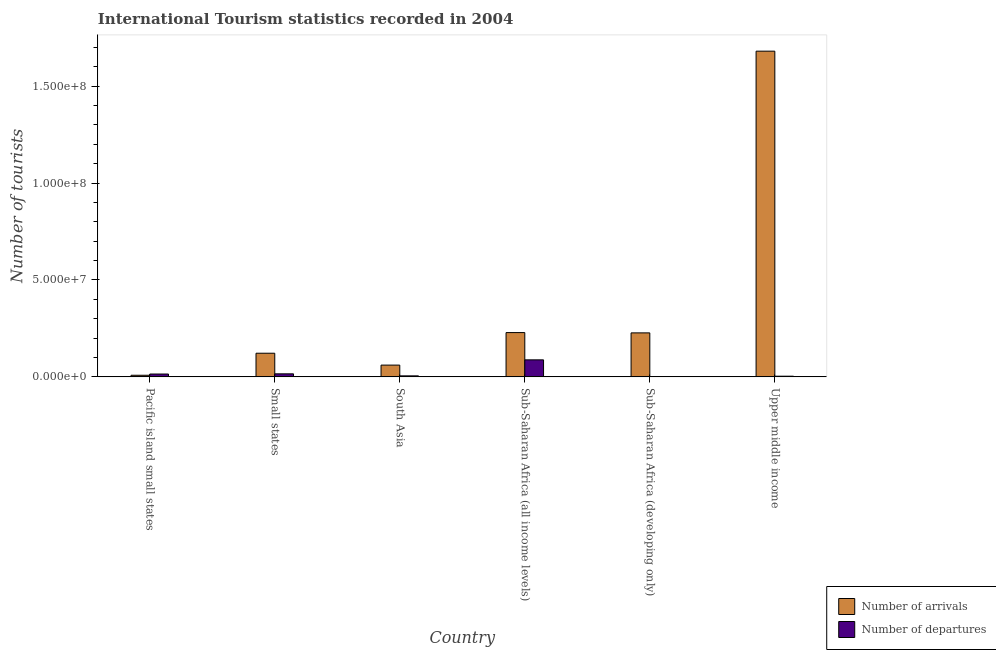Are the number of bars on each tick of the X-axis equal?
Your answer should be compact. Yes. What is the label of the 6th group of bars from the left?
Give a very brief answer. Upper middle income. In how many cases, is the number of bars for a given country not equal to the number of legend labels?
Provide a short and direct response. 0. What is the number of tourist arrivals in Upper middle income?
Ensure brevity in your answer.  1.68e+08. Across all countries, what is the maximum number of tourist arrivals?
Your answer should be compact. 1.68e+08. Across all countries, what is the minimum number of tourist departures?
Ensure brevity in your answer.  1.56e+05. In which country was the number of tourist departures maximum?
Your response must be concise. Sub-Saharan Africa (all income levels). In which country was the number of tourist arrivals minimum?
Give a very brief answer. Pacific island small states. What is the total number of tourist arrivals in the graph?
Provide a succinct answer. 2.33e+08. What is the difference between the number of tourist departures in South Asia and that in Sub-Saharan Africa (all income levels)?
Your response must be concise. -8.27e+06. What is the difference between the number of tourist arrivals in Small states and the number of tourist departures in Sub-Saharan Africa (developing only)?
Offer a very short reply. 1.20e+07. What is the average number of tourist departures per country?
Make the answer very short. 2.14e+06. What is the difference between the number of tourist arrivals and number of tourist departures in South Asia?
Offer a very short reply. 5.56e+06. What is the ratio of the number of tourist arrivals in Pacific island small states to that in Small states?
Offer a terse response. 0.07. What is the difference between the highest and the second highest number of tourist arrivals?
Give a very brief answer. 1.45e+08. What is the difference between the highest and the lowest number of tourist arrivals?
Your answer should be compact. 1.67e+08. In how many countries, is the number of tourist arrivals greater than the average number of tourist arrivals taken over all countries?
Keep it short and to the point. 1. Is the sum of the number of tourist arrivals in Small states and Sub-Saharan Africa (developing only) greater than the maximum number of tourist departures across all countries?
Keep it short and to the point. Yes. What does the 1st bar from the left in South Asia represents?
Offer a very short reply. Number of arrivals. What does the 2nd bar from the right in Upper middle income represents?
Ensure brevity in your answer.  Number of arrivals. How many bars are there?
Keep it short and to the point. 12. Are all the bars in the graph horizontal?
Keep it short and to the point. No. Does the graph contain any zero values?
Ensure brevity in your answer.  No. How many legend labels are there?
Offer a terse response. 2. How are the legend labels stacked?
Keep it short and to the point. Vertical. What is the title of the graph?
Offer a very short reply. International Tourism statistics recorded in 2004. Does "Girls" appear as one of the legend labels in the graph?
Offer a very short reply. No. What is the label or title of the Y-axis?
Offer a terse response. Number of tourists. What is the Number of tourists of Number of arrivals in Pacific island small states?
Your answer should be very brief. 8.31e+05. What is the Number of tourists of Number of departures in Pacific island small states?
Keep it short and to the point. 1.47e+06. What is the Number of tourists in Number of arrivals in Small states?
Provide a short and direct response. 1.22e+07. What is the Number of tourists of Number of departures in Small states?
Your answer should be compact. 1.56e+06. What is the Number of tourists in Number of arrivals in South Asia?
Your answer should be very brief. 6.07e+06. What is the Number of tourists of Number of departures in South Asia?
Offer a very short reply. 5.15e+05. What is the Number of tourists of Number of arrivals in Sub-Saharan Africa (all income levels)?
Provide a short and direct response. 2.28e+07. What is the Number of tourists of Number of departures in Sub-Saharan Africa (all income levels)?
Your answer should be very brief. 8.78e+06. What is the Number of tourists of Number of arrivals in Sub-Saharan Africa (developing only)?
Provide a succinct answer. 2.27e+07. What is the Number of tourists in Number of departures in Sub-Saharan Africa (developing only)?
Ensure brevity in your answer.  1.56e+05. What is the Number of tourists in Number of arrivals in Upper middle income?
Give a very brief answer. 1.68e+08. What is the Number of tourists in Number of departures in Upper middle income?
Give a very brief answer. 3.46e+05. Across all countries, what is the maximum Number of tourists of Number of arrivals?
Your response must be concise. 1.68e+08. Across all countries, what is the maximum Number of tourists of Number of departures?
Make the answer very short. 8.78e+06. Across all countries, what is the minimum Number of tourists in Number of arrivals?
Offer a terse response. 8.31e+05. Across all countries, what is the minimum Number of tourists of Number of departures?
Give a very brief answer. 1.56e+05. What is the total Number of tourists of Number of arrivals in the graph?
Offer a very short reply. 2.33e+08. What is the total Number of tourists in Number of departures in the graph?
Your answer should be compact. 1.28e+07. What is the difference between the Number of tourists in Number of arrivals in Pacific island small states and that in Small states?
Offer a very short reply. -1.14e+07. What is the difference between the Number of tourists in Number of departures in Pacific island small states and that in Small states?
Provide a short and direct response. -9.20e+04. What is the difference between the Number of tourists of Number of arrivals in Pacific island small states and that in South Asia?
Your answer should be compact. -5.24e+06. What is the difference between the Number of tourists of Number of departures in Pacific island small states and that in South Asia?
Ensure brevity in your answer.  9.58e+05. What is the difference between the Number of tourists in Number of arrivals in Pacific island small states and that in Sub-Saharan Africa (all income levels)?
Your answer should be very brief. -2.20e+07. What is the difference between the Number of tourists of Number of departures in Pacific island small states and that in Sub-Saharan Africa (all income levels)?
Provide a short and direct response. -7.31e+06. What is the difference between the Number of tourists of Number of arrivals in Pacific island small states and that in Sub-Saharan Africa (developing only)?
Your answer should be very brief. -2.19e+07. What is the difference between the Number of tourists of Number of departures in Pacific island small states and that in Sub-Saharan Africa (developing only)?
Make the answer very short. 1.32e+06. What is the difference between the Number of tourists in Number of arrivals in Pacific island small states and that in Upper middle income?
Provide a short and direct response. -1.67e+08. What is the difference between the Number of tourists in Number of departures in Pacific island small states and that in Upper middle income?
Your answer should be very brief. 1.13e+06. What is the difference between the Number of tourists of Number of arrivals in Small states and that in South Asia?
Keep it short and to the point. 6.12e+06. What is the difference between the Number of tourists in Number of departures in Small states and that in South Asia?
Ensure brevity in your answer.  1.05e+06. What is the difference between the Number of tourists of Number of arrivals in Small states and that in Sub-Saharan Africa (all income levels)?
Offer a terse response. -1.07e+07. What is the difference between the Number of tourists of Number of departures in Small states and that in Sub-Saharan Africa (all income levels)?
Offer a very short reply. -7.22e+06. What is the difference between the Number of tourists in Number of arrivals in Small states and that in Sub-Saharan Africa (developing only)?
Provide a succinct answer. -1.05e+07. What is the difference between the Number of tourists of Number of departures in Small states and that in Sub-Saharan Africa (developing only)?
Provide a succinct answer. 1.41e+06. What is the difference between the Number of tourists of Number of arrivals in Small states and that in Upper middle income?
Ensure brevity in your answer.  -1.56e+08. What is the difference between the Number of tourists of Number of departures in Small states and that in Upper middle income?
Provide a succinct answer. 1.22e+06. What is the difference between the Number of tourists in Number of arrivals in South Asia and that in Sub-Saharan Africa (all income levels)?
Your answer should be very brief. -1.68e+07. What is the difference between the Number of tourists of Number of departures in South Asia and that in Sub-Saharan Africa (all income levels)?
Keep it short and to the point. -8.27e+06. What is the difference between the Number of tourists of Number of arrivals in South Asia and that in Sub-Saharan Africa (developing only)?
Your response must be concise. -1.66e+07. What is the difference between the Number of tourists of Number of departures in South Asia and that in Sub-Saharan Africa (developing only)?
Your answer should be compact. 3.59e+05. What is the difference between the Number of tourists of Number of arrivals in South Asia and that in Upper middle income?
Your response must be concise. -1.62e+08. What is the difference between the Number of tourists in Number of departures in South Asia and that in Upper middle income?
Keep it short and to the point. 1.69e+05. What is the difference between the Number of tourists in Number of arrivals in Sub-Saharan Africa (all income levels) and that in Sub-Saharan Africa (developing only)?
Your response must be concise. 1.53e+05. What is the difference between the Number of tourists of Number of departures in Sub-Saharan Africa (all income levels) and that in Sub-Saharan Africa (developing only)?
Give a very brief answer. 8.63e+06. What is the difference between the Number of tourists of Number of arrivals in Sub-Saharan Africa (all income levels) and that in Upper middle income?
Offer a very short reply. -1.45e+08. What is the difference between the Number of tourists of Number of departures in Sub-Saharan Africa (all income levels) and that in Upper middle income?
Offer a terse response. 8.44e+06. What is the difference between the Number of tourists of Number of arrivals in Sub-Saharan Africa (developing only) and that in Upper middle income?
Offer a very short reply. -1.45e+08. What is the difference between the Number of tourists of Number of arrivals in Pacific island small states and the Number of tourists of Number of departures in Small states?
Your answer should be very brief. -7.34e+05. What is the difference between the Number of tourists of Number of arrivals in Pacific island small states and the Number of tourists of Number of departures in South Asia?
Give a very brief answer. 3.16e+05. What is the difference between the Number of tourists in Number of arrivals in Pacific island small states and the Number of tourists in Number of departures in Sub-Saharan Africa (all income levels)?
Offer a very short reply. -7.95e+06. What is the difference between the Number of tourists of Number of arrivals in Pacific island small states and the Number of tourists of Number of departures in Sub-Saharan Africa (developing only)?
Keep it short and to the point. 6.75e+05. What is the difference between the Number of tourists in Number of arrivals in Pacific island small states and the Number of tourists in Number of departures in Upper middle income?
Keep it short and to the point. 4.85e+05. What is the difference between the Number of tourists of Number of arrivals in Small states and the Number of tourists of Number of departures in South Asia?
Ensure brevity in your answer.  1.17e+07. What is the difference between the Number of tourists in Number of arrivals in Small states and the Number of tourists in Number of departures in Sub-Saharan Africa (all income levels)?
Provide a short and direct response. 3.41e+06. What is the difference between the Number of tourists in Number of arrivals in Small states and the Number of tourists in Number of departures in Sub-Saharan Africa (developing only)?
Offer a terse response. 1.20e+07. What is the difference between the Number of tourists in Number of arrivals in Small states and the Number of tourists in Number of departures in Upper middle income?
Make the answer very short. 1.19e+07. What is the difference between the Number of tourists of Number of arrivals in South Asia and the Number of tourists of Number of departures in Sub-Saharan Africa (all income levels)?
Ensure brevity in your answer.  -2.71e+06. What is the difference between the Number of tourists of Number of arrivals in South Asia and the Number of tourists of Number of departures in Sub-Saharan Africa (developing only)?
Provide a succinct answer. 5.92e+06. What is the difference between the Number of tourists of Number of arrivals in South Asia and the Number of tourists of Number of departures in Upper middle income?
Give a very brief answer. 5.73e+06. What is the difference between the Number of tourists in Number of arrivals in Sub-Saharan Africa (all income levels) and the Number of tourists in Number of departures in Sub-Saharan Africa (developing only)?
Ensure brevity in your answer.  2.27e+07. What is the difference between the Number of tourists of Number of arrivals in Sub-Saharan Africa (all income levels) and the Number of tourists of Number of departures in Upper middle income?
Your answer should be compact. 2.25e+07. What is the difference between the Number of tourists in Number of arrivals in Sub-Saharan Africa (developing only) and the Number of tourists in Number of departures in Upper middle income?
Offer a very short reply. 2.23e+07. What is the average Number of tourists in Number of arrivals per country?
Your response must be concise. 3.88e+07. What is the average Number of tourists in Number of departures per country?
Offer a terse response. 2.14e+06. What is the difference between the Number of tourists in Number of arrivals and Number of tourists in Number of departures in Pacific island small states?
Your response must be concise. -6.42e+05. What is the difference between the Number of tourists in Number of arrivals and Number of tourists in Number of departures in Small states?
Provide a succinct answer. 1.06e+07. What is the difference between the Number of tourists in Number of arrivals and Number of tourists in Number of departures in South Asia?
Ensure brevity in your answer.  5.56e+06. What is the difference between the Number of tourists in Number of arrivals and Number of tourists in Number of departures in Sub-Saharan Africa (all income levels)?
Offer a terse response. 1.41e+07. What is the difference between the Number of tourists in Number of arrivals and Number of tourists in Number of departures in Sub-Saharan Africa (developing only)?
Give a very brief answer. 2.25e+07. What is the difference between the Number of tourists in Number of arrivals and Number of tourists in Number of departures in Upper middle income?
Keep it short and to the point. 1.68e+08. What is the ratio of the Number of tourists of Number of arrivals in Pacific island small states to that in Small states?
Offer a terse response. 0.07. What is the ratio of the Number of tourists of Number of departures in Pacific island small states to that in Small states?
Give a very brief answer. 0.94. What is the ratio of the Number of tourists in Number of arrivals in Pacific island small states to that in South Asia?
Offer a terse response. 0.14. What is the ratio of the Number of tourists in Number of departures in Pacific island small states to that in South Asia?
Your response must be concise. 2.86. What is the ratio of the Number of tourists of Number of arrivals in Pacific island small states to that in Sub-Saharan Africa (all income levels)?
Offer a very short reply. 0.04. What is the ratio of the Number of tourists of Number of departures in Pacific island small states to that in Sub-Saharan Africa (all income levels)?
Provide a succinct answer. 0.17. What is the ratio of the Number of tourists in Number of arrivals in Pacific island small states to that in Sub-Saharan Africa (developing only)?
Your answer should be very brief. 0.04. What is the ratio of the Number of tourists of Number of departures in Pacific island small states to that in Sub-Saharan Africa (developing only)?
Offer a terse response. 9.44. What is the ratio of the Number of tourists in Number of arrivals in Pacific island small states to that in Upper middle income?
Offer a very short reply. 0. What is the ratio of the Number of tourists of Number of departures in Pacific island small states to that in Upper middle income?
Your answer should be compact. 4.26. What is the ratio of the Number of tourists in Number of arrivals in Small states to that in South Asia?
Make the answer very short. 2.01. What is the ratio of the Number of tourists of Number of departures in Small states to that in South Asia?
Your response must be concise. 3.04. What is the ratio of the Number of tourists of Number of arrivals in Small states to that in Sub-Saharan Africa (all income levels)?
Provide a succinct answer. 0.53. What is the ratio of the Number of tourists of Number of departures in Small states to that in Sub-Saharan Africa (all income levels)?
Offer a terse response. 0.18. What is the ratio of the Number of tourists in Number of arrivals in Small states to that in Sub-Saharan Africa (developing only)?
Give a very brief answer. 0.54. What is the ratio of the Number of tourists in Number of departures in Small states to that in Sub-Saharan Africa (developing only)?
Provide a short and direct response. 10.03. What is the ratio of the Number of tourists in Number of arrivals in Small states to that in Upper middle income?
Your response must be concise. 0.07. What is the ratio of the Number of tourists in Number of departures in Small states to that in Upper middle income?
Your answer should be very brief. 4.52. What is the ratio of the Number of tourists in Number of arrivals in South Asia to that in Sub-Saharan Africa (all income levels)?
Offer a terse response. 0.27. What is the ratio of the Number of tourists in Number of departures in South Asia to that in Sub-Saharan Africa (all income levels)?
Your answer should be compact. 0.06. What is the ratio of the Number of tourists in Number of arrivals in South Asia to that in Sub-Saharan Africa (developing only)?
Your response must be concise. 0.27. What is the ratio of the Number of tourists in Number of departures in South Asia to that in Sub-Saharan Africa (developing only)?
Give a very brief answer. 3.3. What is the ratio of the Number of tourists in Number of arrivals in South Asia to that in Upper middle income?
Give a very brief answer. 0.04. What is the ratio of the Number of tourists of Number of departures in South Asia to that in Upper middle income?
Offer a very short reply. 1.49. What is the ratio of the Number of tourists of Number of arrivals in Sub-Saharan Africa (all income levels) to that in Sub-Saharan Africa (developing only)?
Provide a succinct answer. 1.01. What is the ratio of the Number of tourists in Number of departures in Sub-Saharan Africa (all income levels) to that in Sub-Saharan Africa (developing only)?
Your answer should be compact. 56.3. What is the ratio of the Number of tourists in Number of arrivals in Sub-Saharan Africa (all income levels) to that in Upper middle income?
Make the answer very short. 0.14. What is the ratio of the Number of tourists of Number of departures in Sub-Saharan Africa (all income levels) to that in Upper middle income?
Give a very brief answer. 25.38. What is the ratio of the Number of tourists in Number of arrivals in Sub-Saharan Africa (developing only) to that in Upper middle income?
Your answer should be compact. 0.14. What is the ratio of the Number of tourists in Number of departures in Sub-Saharan Africa (developing only) to that in Upper middle income?
Offer a very short reply. 0.45. What is the difference between the highest and the second highest Number of tourists of Number of arrivals?
Your answer should be very brief. 1.45e+08. What is the difference between the highest and the second highest Number of tourists of Number of departures?
Your response must be concise. 7.22e+06. What is the difference between the highest and the lowest Number of tourists of Number of arrivals?
Provide a succinct answer. 1.67e+08. What is the difference between the highest and the lowest Number of tourists in Number of departures?
Make the answer very short. 8.63e+06. 